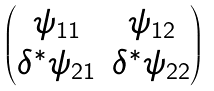Convert formula to latex. <formula><loc_0><loc_0><loc_500><loc_500>\begin{pmatrix} \psi _ { 1 1 } & \psi _ { 1 2 } \\ \delta ^ { * } \psi _ { 2 1 } & \delta ^ { * } \psi _ { 2 2 } \end{pmatrix}</formula> 